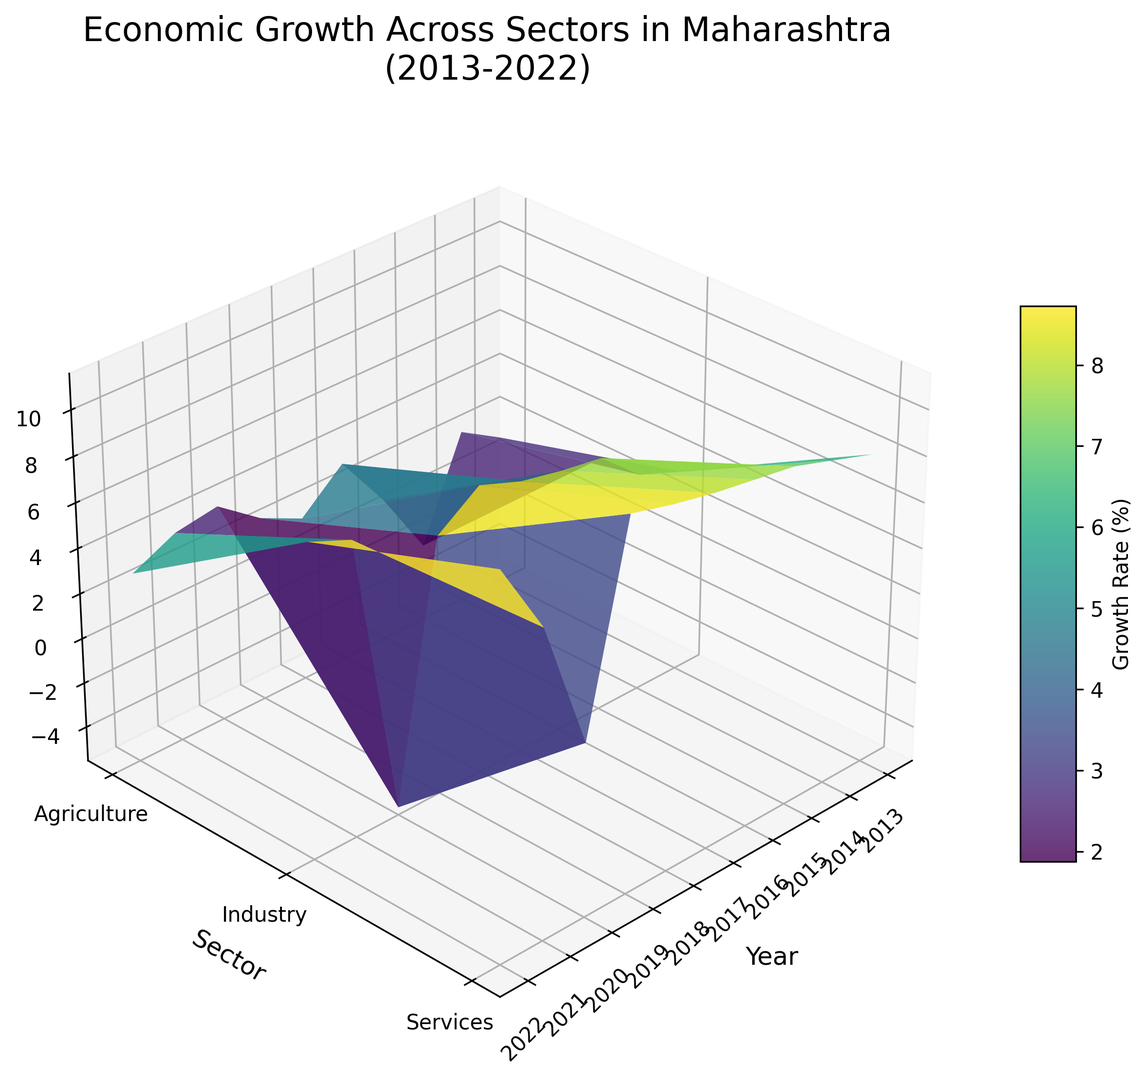What is the highest growth rate in the Services sector during the period? Locate the Services sector, and observe the highest peak on the Z-axis within this sector. The highest growth rate is at the year 2022.
Answer: 11.2 Which year experienced the lowest growth rate in the Industry sector? Look at the Industry sector line and identify the year that corresponds to the lowest point on the Z-axis. This year is 2020.
Answer: 2020 Compare the Agriculture sector's growth rates in 2015 and 2022. Which year had a higher growth rate? Find the Agriculture sector and compare the height of the bars for the years 2015 and 2022. The 2022 bar is taller than the 2015 bar.
Answer: 2022 What is the average growth rate of the Services sector from 2013 to 2022? Add all the growth rates of the Services sector from 2013 to 2022, then divide by the number of years. (8.1+8.7+9.3+9.6+9.9+10.3+10.8+2.1+7.9+11.2)/10 = 88.9/10.
Answer: 8.89 Between Industry and Services sectors in 2017, which had a higher growth rate? For 2017, compare the heights of the bars in the Industry and Services sectors. The Services sector bar is taller.
Answer: Services Identify the years with negative growth rates for the Agriculture sector. Inspect the Agriculture sector and find the years with bars below the zero plane. The year that matches this criterion is 2015.
Answer: 2015 Which sector had the most volatile growth rate changes over the decade? Compare the peaks and valleys along the Z-axis for each sector. The Agriculture sector shows the most noticeable fluctuations.
Answer: Agriculture In which year did all sectors show positive growth rates? Identify the year where all sector bars are above the zero line. The year meeting this condition is 2013.
Answer: 2013 By how much did the growth rate in the Industry sector change from 2020 to 2022? Locate the Industry sector and compare the bar heights for the years 2020 and 2022. Calculate the difference: 8.3 - (-5.2) = 13.5.
Answer: 13.5 Is the growth rate trend for the Services sector consistently upward from 2013 to 2019? Examine the Services sector and observe the bar heights from 2013 to 2019. The heights increase consistently during these years.
Answer: Yes 